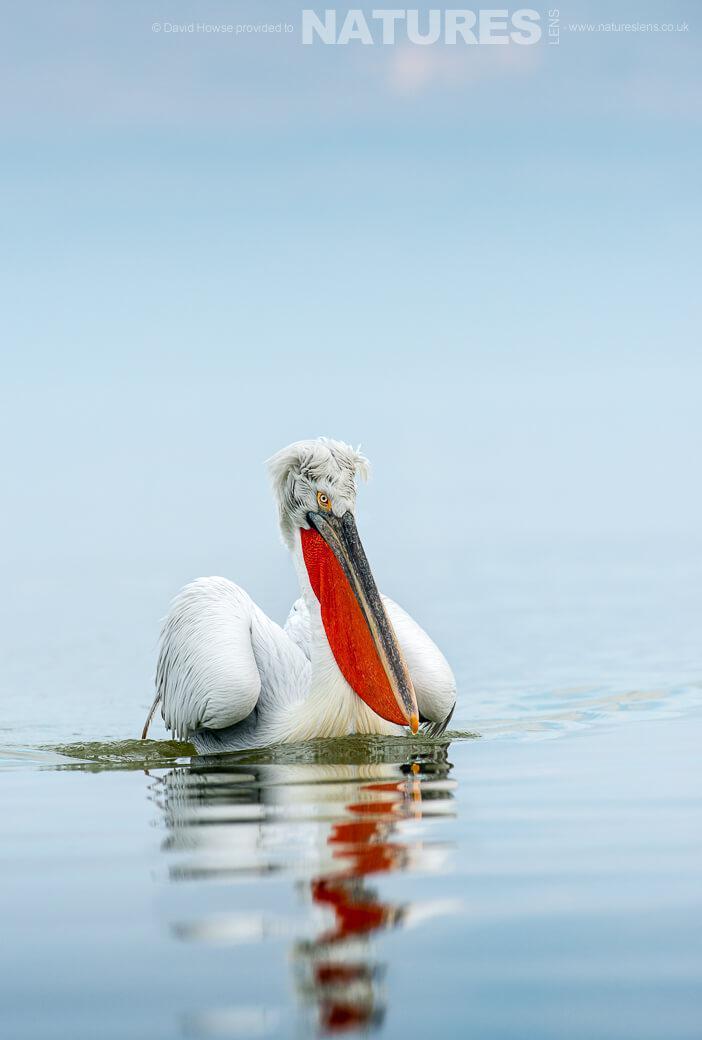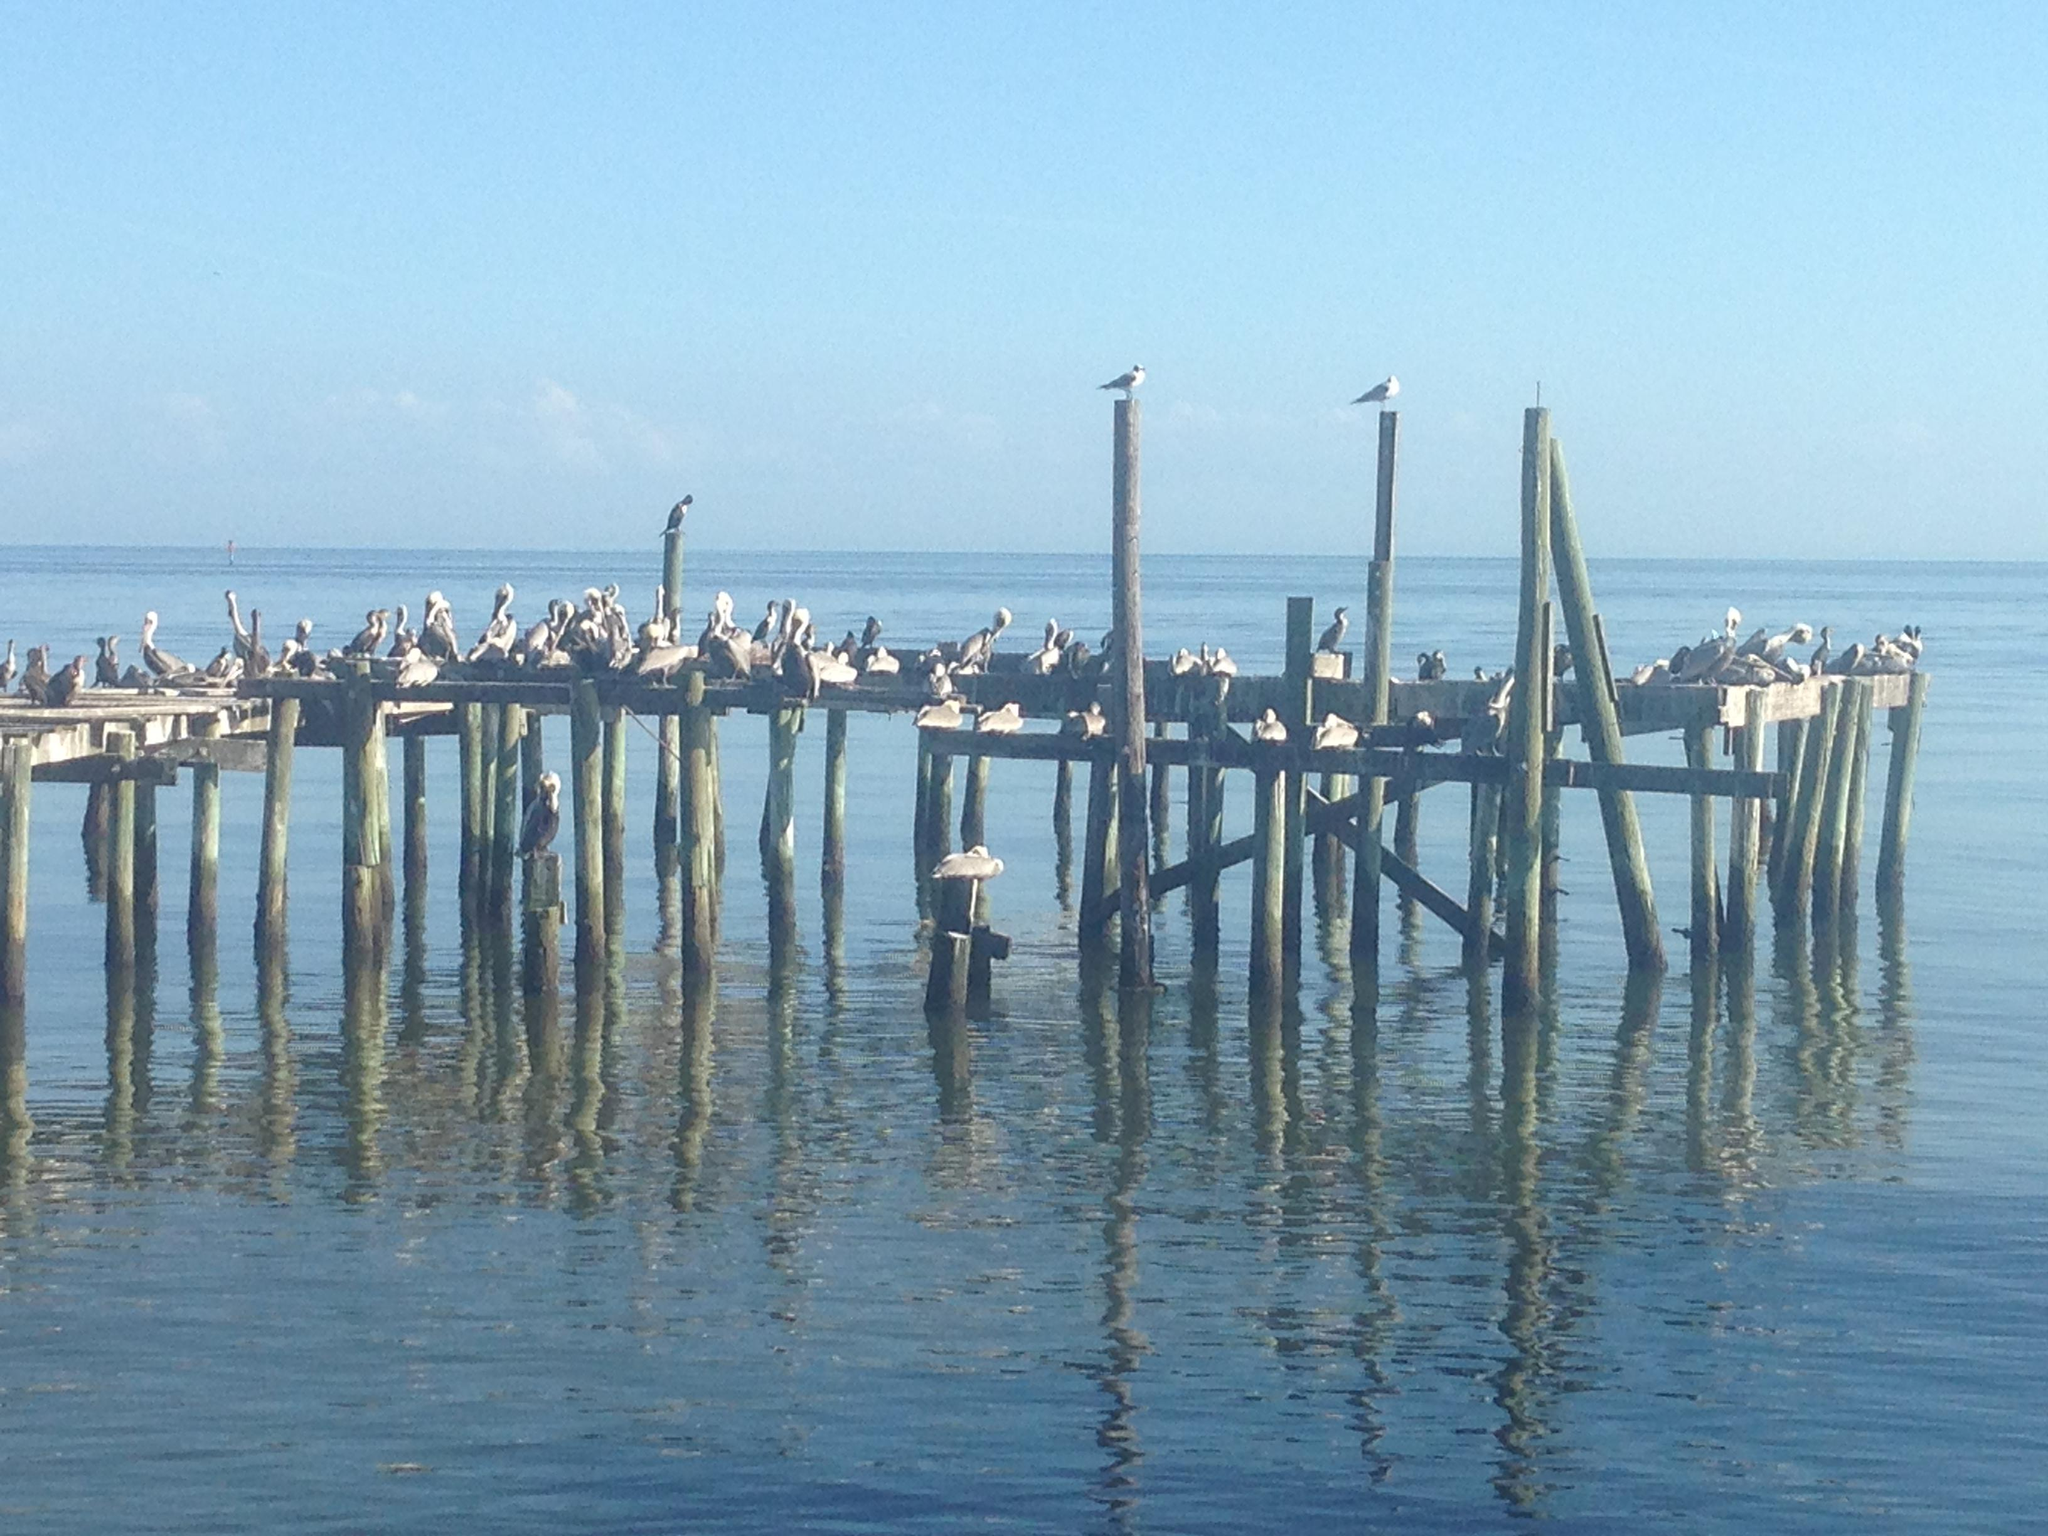The first image is the image on the left, the second image is the image on the right. Given the left and right images, does the statement "One image includes pelicans on a wooden pier, and the other image shows at least one pelican in the water." hold true? Answer yes or no. Yes. The first image is the image on the left, the second image is the image on the right. Examine the images to the left and right. Is the description "At least one pelican is flying." accurate? Answer yes or no. No. 